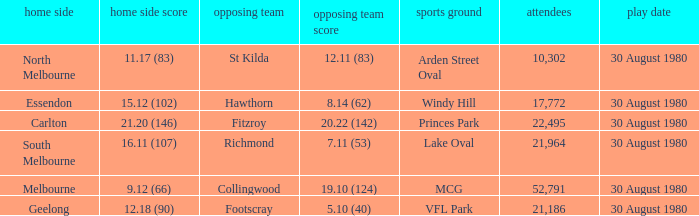What is the home team score at lake oval? 16.11 (107). 